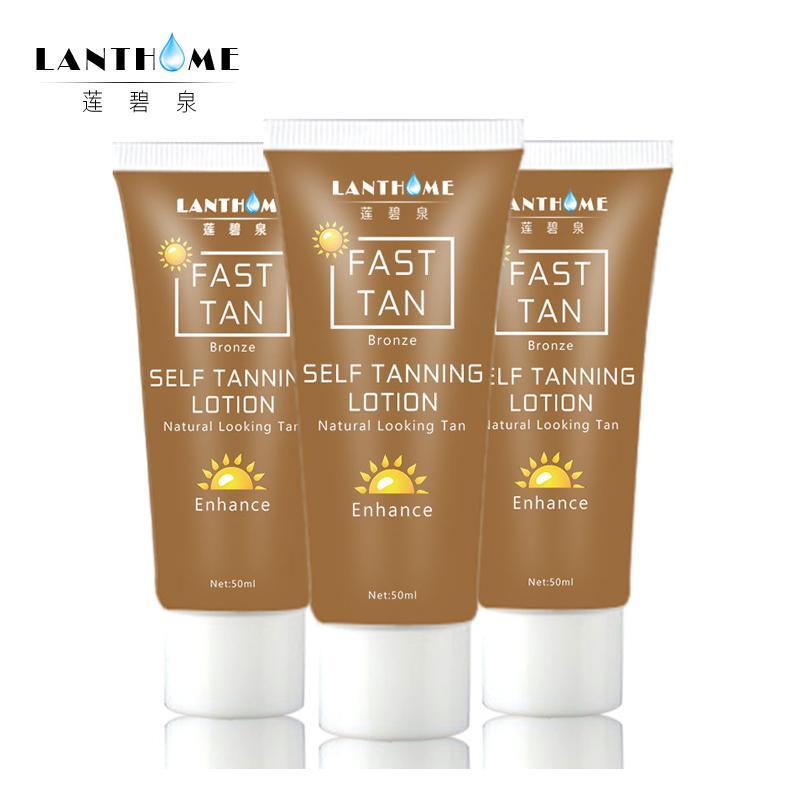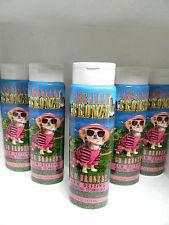The first image is the image on the left, the second image is the image on the right. Given the left and right images, does the statement "Product is in travel, plastic packages rather than bottles." hold true? Answer yes or no. No. 